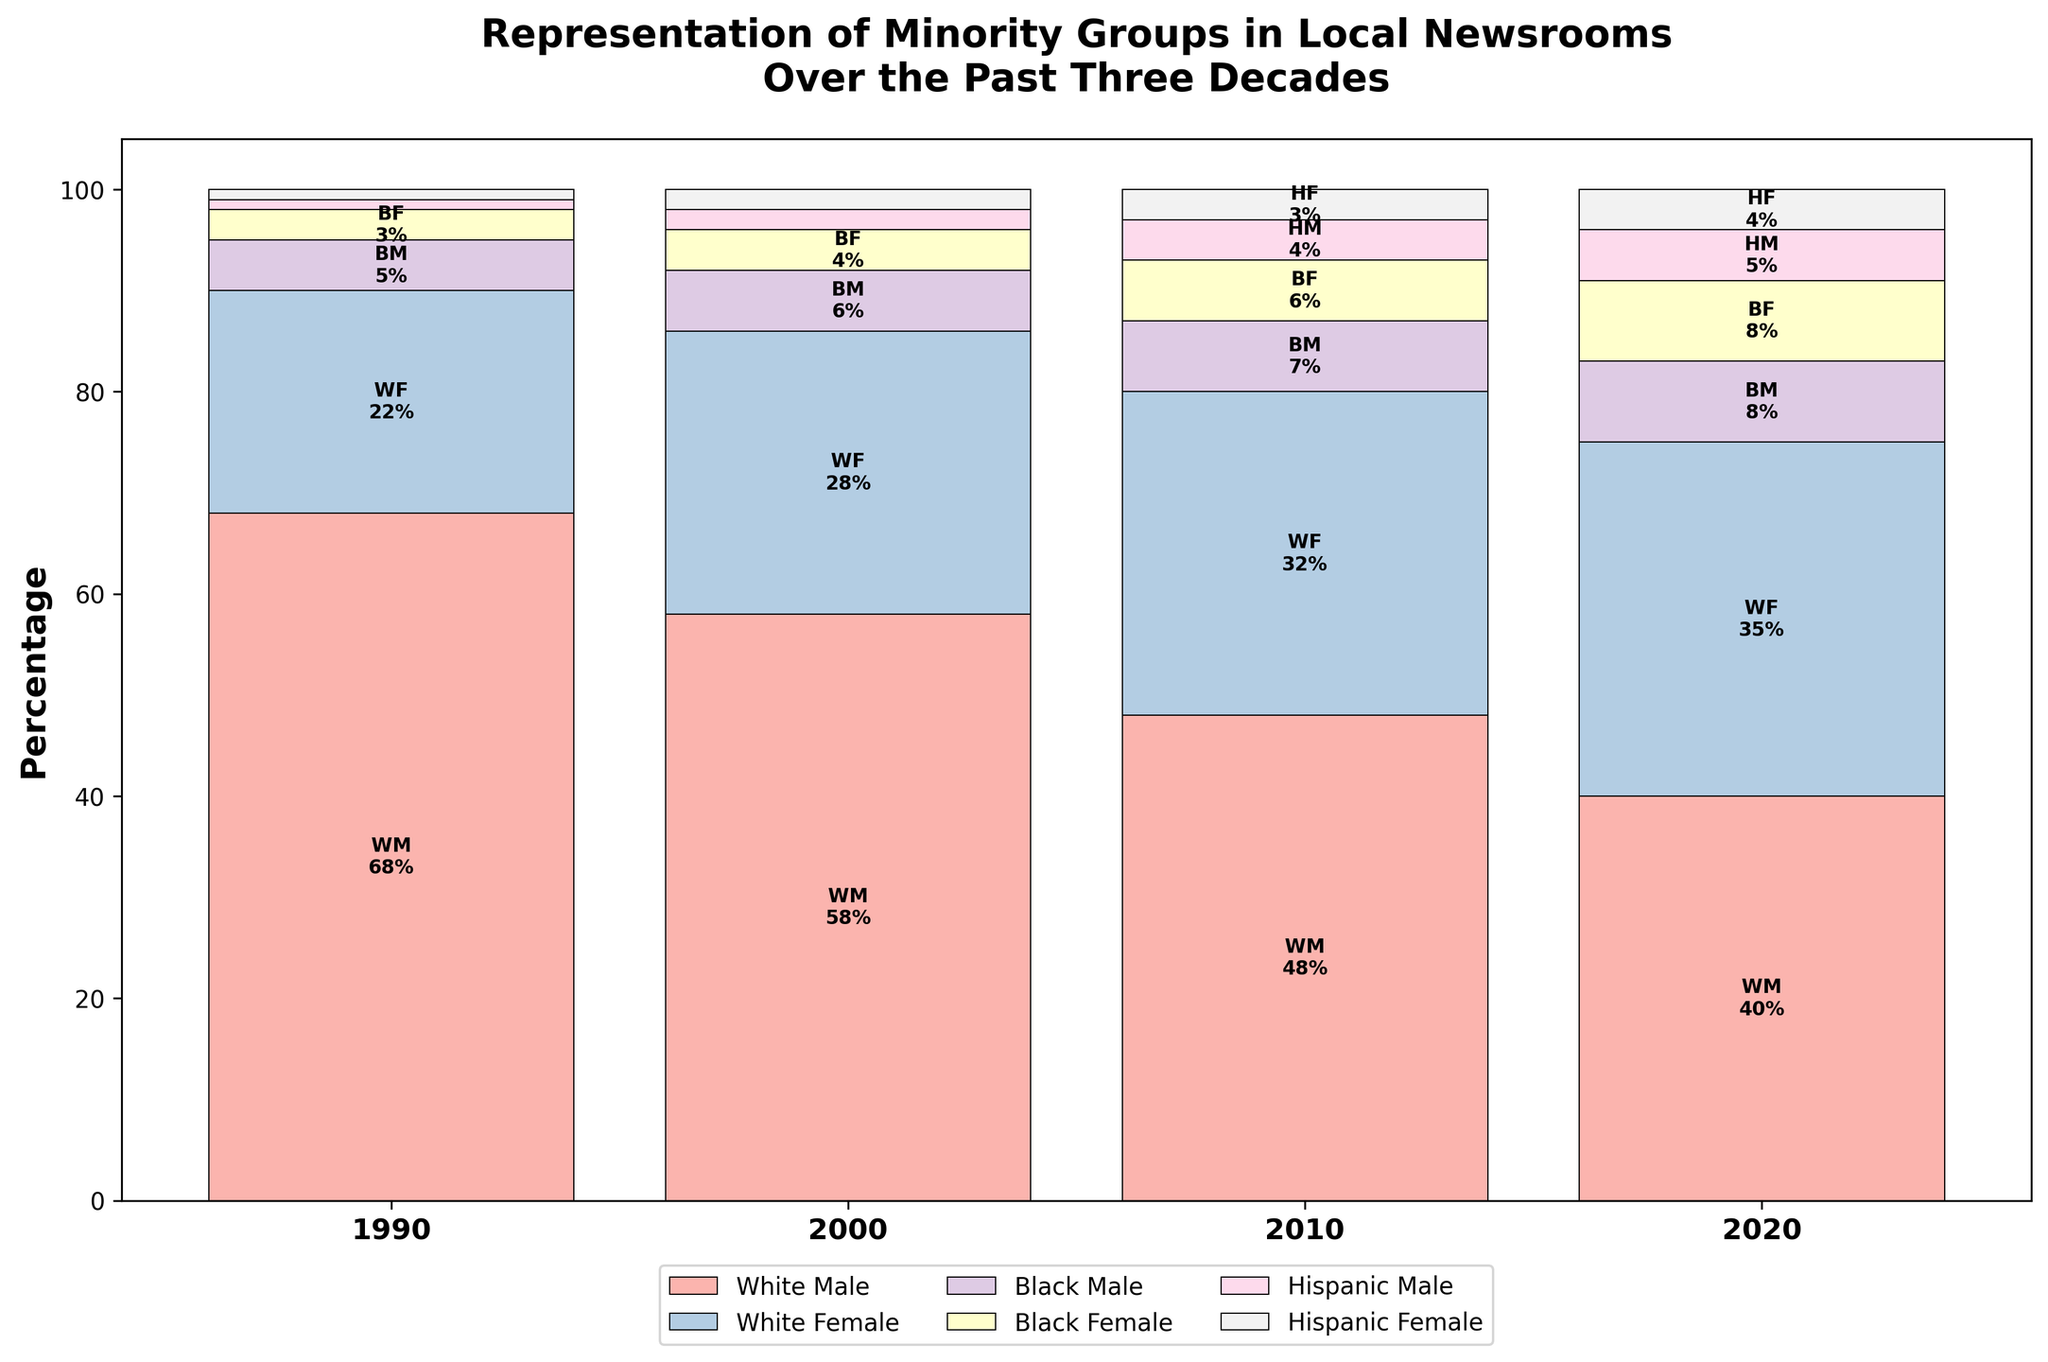what is the title of the plot? The plot title is usually displayed at the top of the chart. Here, it states "Representation of Minority Groups in Local Newsrooms Over the Past Three Decades".
Answer: Representation of Minority Groups in Local Newsrooms Over the Past Three Decades How many years are represented in the plot? To find the number of years represented, look at the x-axis, which should have distinct tick marks for each year. In this plot, there are four years: 1990, 2000, 2010, and 2020.
Answer: 4 Which ethnicity and gender group had the highest representation in 1990? For the year 1990, examine the bars and their labels. The tallest bar representing the largest percentage is for White Males at 68%.
Answer: White Male How did the representation of Hispanic Females change from 1990 to 2020? Check the height and labels of bars for Hispanic Females across the years. In 1990, it was 1%, and in 2020, it increased to 4%.
Answer: Increased by 3% What is the total percentage of White representation (Male and Female) for the year 2020? Sum up the percentages for White Males and White Females in 2020: 40% (Male) + 35% (Female) = 75%.
Answer: 75% Which year had the highest cumulative representation of Black groups (Male and Female)? Sum the percentages of Black Males and Black Females for each year and compare: 1990 (8%), 2000 (10%), 2010 (13%), 2020 (16%). The highest is 2020 with 16%.
Answer: 2020 How does the overall representation of females (all ethnicities) in 2000 compare to that in 2020? Add the percentages of all female groups for the years 2000 and 2020: 2000 (White Female 28% + Black Female 4% + Hispanic Female 2% = 34%), 2020 (White Female 35% + Black Female 8% + Hispanic Female 4% = 47%). The comparison shows an increase from 34% in 2000 to 47% in 2020.
Answer: Increased by 13% Which year shows the most balanced gender representation within the White ethnicity? Compare the percentages of White Males and Females for each year. The most balanced year is where the percentages are closest: in 2020 (40% Male, 35% Female), which is a 5% difference.
Answer: 2020 Which minority group (non-White) had the most significant increase in representation from 1990 to 2020? Compare the percentages between 1990 and 2020 for each minority group: Black Male (increase by 3%), Black Female (increase by 5%), Hispanic Male (increase by 4%), Hispanic Female (increase by 3%). Black Female had the most significant increase of 5%.
Answer: Black Female What is the overall trend in the representation of White Males from 1990 to 2020? Observing the percentages of White Males over the years: 1990 (68%), 2000 (58%), 2010 (48%), 2020 (40%). The trend shows a consistent decrease.
Answer: Decreasing 